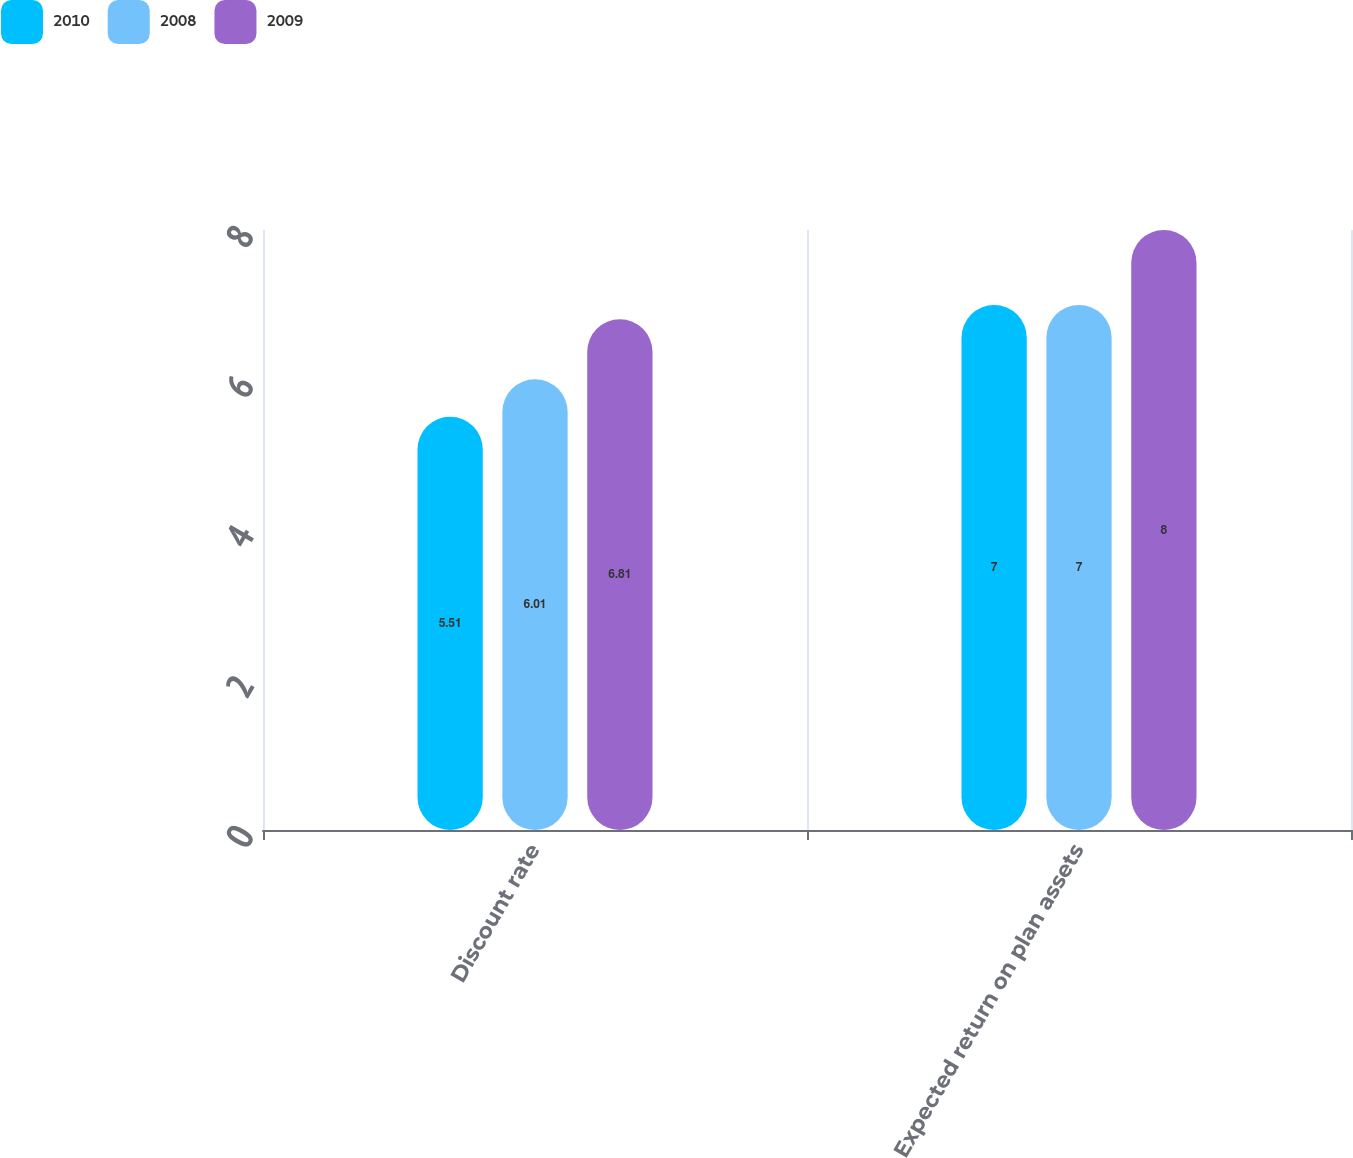Convert chart to OTSL. <chart><loc_0><loc_0><loc_500><loc_500><stacked_bar_chart><ecel><fcel>Discount rate<fcel>Expected return on plan assets<nl><fcel>2010<fcel>5.51<fcel>7<nl><fcel>2008<fcel>6.01<fcel>7<nl><fcel>2009<fcel>6.81<fcel>8<nl></chart> 